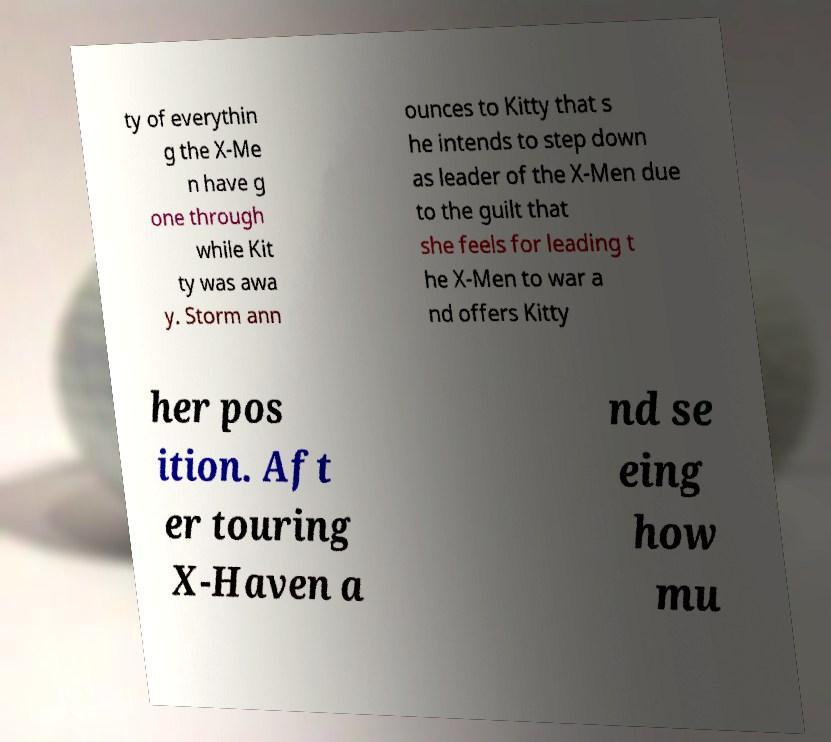Can you accurately transcribe the text from the provided image for me? ty of everythin g the X-Me n have g one through while Kit ty was awa y. Storm ann ounces to Kitty that s he intends to step down as leader of the X-Men due to the guilt that she feels for leading t he X-Men to war a nd offers Kitty her pos ition. Aft er touring X-Haven a nd se eing how mu 